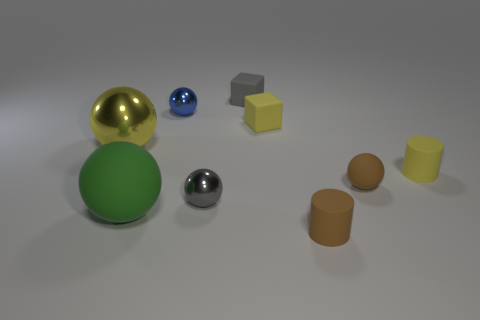What number of tiny yellow rubber blocks are in front of the cylinder that is behind the gray shiny ball?
Provide a short and direct response. 0. There is a matte sphere that is right of the big sphere in front of the gray shiny thing to the left of the small matte ball; what is its size?
Your answer should be very brief. Small. There is a object that is left of the big matte ball; is its color the same as the big rubber thing?
Make the answer very short. No. What is the size of the green object that is the same shape as the gray metal thing?
Make the answer very short. Large. How many objects are either tiny matte things in front of the gray cube or matte things that are left of the gray matte block?
Offer a terse response. 5. What shape is the small metal thing that is to the right of the small metal ball that is behind the small yellow cylinder?
Your response must be concise. Sphere. Are there any other things of the same color as the tiny rubber ball?
Offer a terse response. Yes. Is there anything else that has the same size as the yellow cube?
Your answer should be very brief. Yes. What number of things are either gray matte cylinders or small blue metal spheres?
Provide a succinct answer. 1. Is there a yellow metal sphere of the same size as the blue shiny sphere?
Ensure brevity in your answer.  No. 